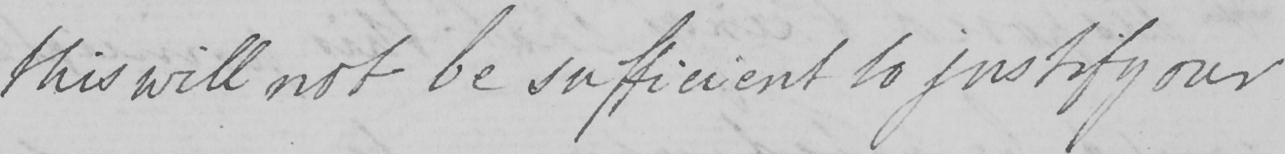What is written in this line of handwriting? this will not be sufficient to justify our 